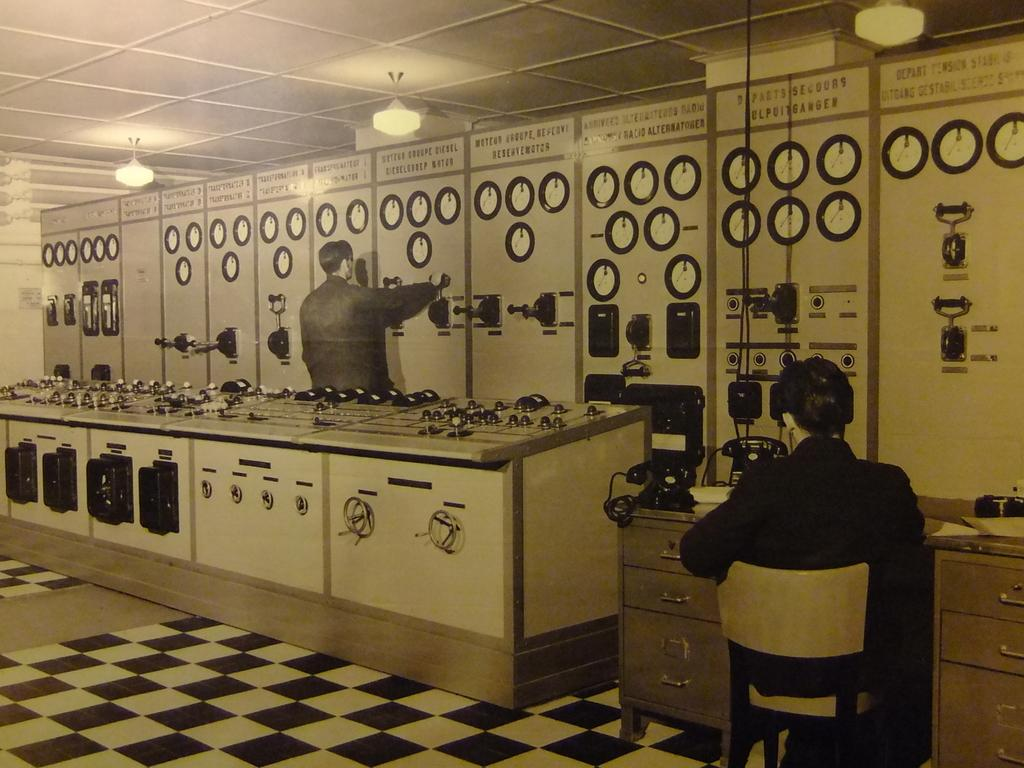What is the person on the left side of the image doing? The person on the left is operating a machine. What is the person on the right side of the image doing? The person on the right is sitting in front of a table. What can be found on the table in the image? The table has telephones on it. What type of pest can be seen crawling on the table in the image? There are no pests visible on the table in the image. What fact is being discussed by the person on the left in the image? The image does not provide any information about a fact being discussed by the person on the left. 